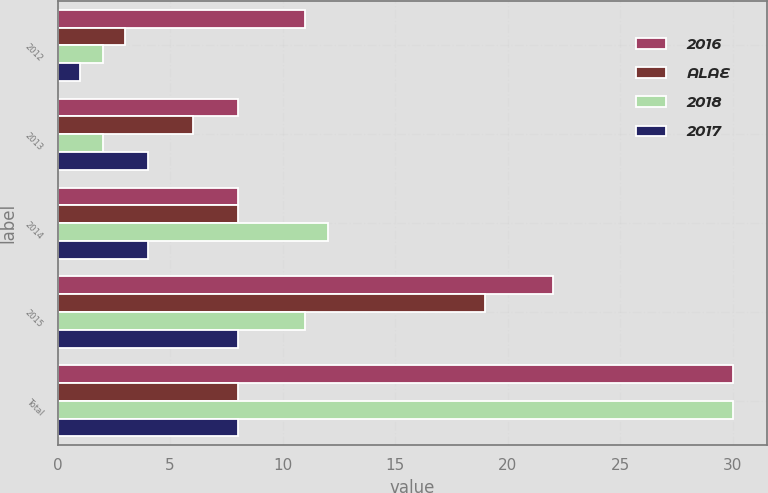Convert chart to OTSL. <chart><loc_0><loc_0><loc_500><loc_500><stacked_bar_chart><ecel><fcel>2012<fcel>2013<fcel>2014<fcel>2015<fcel>Total<nl><fcel>2016<fcel>11<fcel>8<fcel>8<fcel>22<fcel>30<nl><fcel>ALAE<fcel>3<fcel>6<fcel>8<fcel>19<fcel>8<nl><fcel>2018<fcel>2<fcel>2<fcel>12<fcel>11<fcel>30<nl><fcel>2017<fcel>1<fcel>4<fcel>4<fcel>8<fcel>8<nl></chart> 